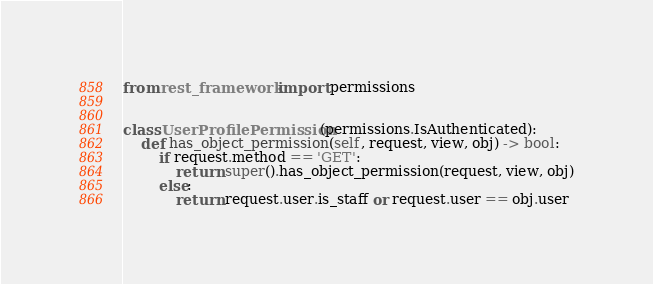<code> <loc_0><loc_0><loc_500><loc_500><_Python_>from rest_framework import permissions


class UserProfilePermission(permissions.IsAuthenticated):
    def has_object_permission(self, request, view, obj) -> bool:
        if request.method == 'GET':
            return super().has_object_permission(request, view, obj)
        else:
            return request.user.is_staff or request.user == obj.user
</code> 